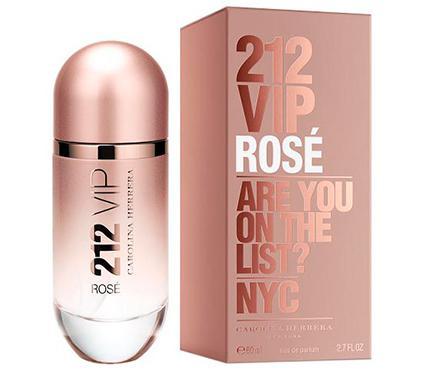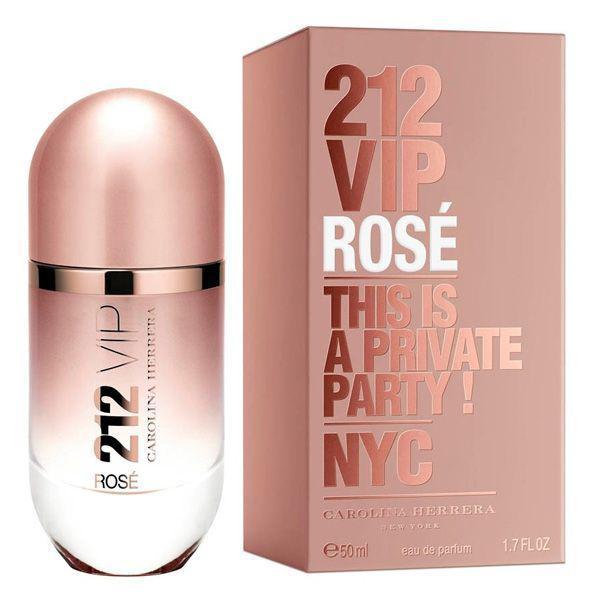The first image is the image on the left, the second image is the image on the right. Given the left and right images, does the statement "The perfume in the image on the left is capsule in shape." hold true? Answer yes or no. Yes. The first image is the image on the left, the second image is the image on the right. Evaluate the accuracy of this statement regarding the images: "At least one image shows an upright capsule-shaped item next to its box.". Is it true? Answer yes or no. Yes. 